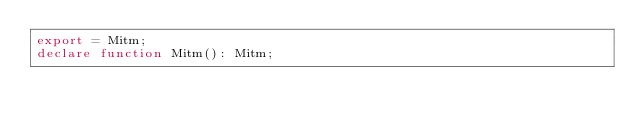<code> <loc_0><loc_0><loc_500><loc_500><_TypeScript_>export = Mitm;
declare function Mitm(): Mitm;
</code> 